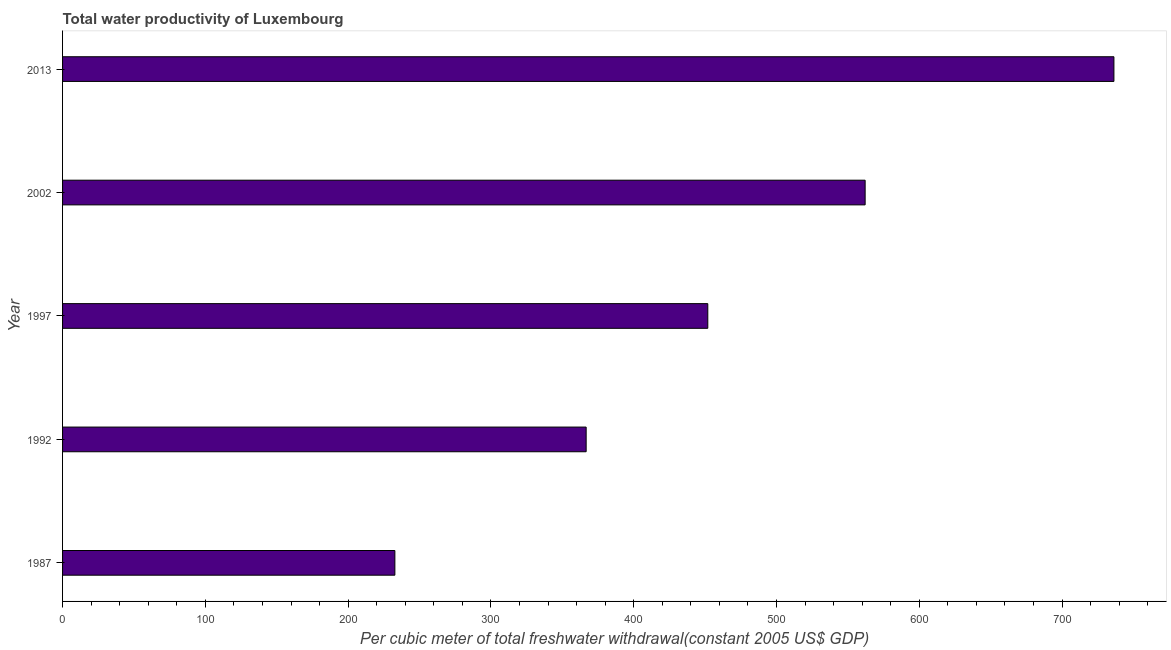Does the graph contain any zero values?
Ensure brevity in your answer.  No. Does the graph contain grids?
Provide a short and direct response. No. What is the title of the graph?
Your answer should be compact. Total water productivity of Luxembourg. What is the label or title of the X-axis?
Your answer should be compact. Per cubic meter of total freshwater withdrawal(constant 2005 US$ GDP). What is the total water productivity in 1987?
Your answer should be compact. 232.74. Across all years, what is the maximum total water productivity?
Provide a short and direct response. 736.35. Across all years, what is the minimum total water productivity?
Provide a short and direct response. 232.74. In which year was the total water productivity maximum?
Ensure brevity in your answer.  2013. What is the sum of the total water productivity?
Ensure brevity in your answer.  2349.81. What is the difference between the total water productivity in 1987 and 2013?
Your answer should be very brief. -503.6. What is the average total water productivity per year?
Ensure brevity in your answer.  469.96. What is the median total water productivity?
Make the answer very short. 451.9. In how many years, is the total water productivity greater than 360 US$?
Ensure brevity in your answer.  4. What is the ratio of the total water productivity in 1987 to that in 1997?
Ensure brevity in your answer.  0.52. Is the total water productivity in 1987 less than that in 2013?
Make the answer very short. Yes. What is the difference between the highest and the second highest total water productivity?
Offer a very short reply. 174.24. Is the sum of the total water productivity in 1987 and 1992 greater than the maximum total water productivity across all years?
Offer a terse response. No. What is the difference between the highest and the lowest total water productivity?
Provide a succinct answer. 503.6. How many bars are there?
Your response must be concise. 5. What is the difference between two consecutive major ticks on the X-axis?
Ensure brevity in your answer.  100. What is the Per cubic meter of total freshwater withdrawal(constant 2005 US$ GDP) of 1987?
Offer a terse response. 232.74. What is the Per cubic meter of total freshwater withdrawal(constant 2005 US$ GDP) of 1992?
Ensure brevity in your answer.  366.71. What is the Per cubic meter of total freshwater withdrawal(constant 2005 US$ GDP) of 1997?
Keep it short and to the point. 451.9. What is the Per cubic meter of total freshwater withdrawal(constant 2005 US$ GDP) in 2002?
Your answer should be compact. 562.1. What is the Per cubic meter of total freshwater withdrawal(constant 2005 US$ GDP) in 2013?
Your response must be concise. 736.35. What is the difference between the Per cubic meter of total freshwater withdrawal(constant 2005 US$ GDP) in 1987 and 1992?
Your answer should be compact. -133.97. What is the difference between the Per cubic meter of total freshwater withdrawal(constant 2005 US$ GDP) in 1987 and 1997?
Your answer should be very brief. -219.16. What is the difference between the Per cubic meter of total freshwater withdrawal(constant 2005 US$ GDP) in 1987 and 2002?
Keep it short and to the point. -329.36. What is the difference between the Per cubic meter of total freshwater withdrawal(constant 2005 US$ GDP) in 1987 and 2013?
Give a very brief answer. -503.6. What is the difference between the Per cubic meter of total freshwater withdrawal(constant 2005 US$ GDP) in 1992 and 1997?
Keep it short and to the point. -85.19. What is the difference between the Per cubic meter of total freshwater withdrawal(constant 2005 US$ GDP) in 1992 and 2002?
Give a very brief answer. -195.39. What is the difference between the Per cubic meter of total freshwater withdrawal(constant 2005 US$ GDP) in 1992 and 2013?
Your answer should be very brief. -369.63. What is the difference between the Per cubic meter of total freshwater withdrawal(constant 2005 US$ GDP) in 1997 and 2002?
Provide a short and direct response. -110.2. What is the difference between the Per cubic meter of total freshwater withdrawal(constant 2005 US$ GDP) in 1997 and 2013?
Ensure brevity in your answer.  -284.44. What is the difference between the Per cubic meter of total freshwater withdrawal(constant 2005 US$ GDP) in 2002 and 2013?
Your answer should be very brief. -174.24. What is the ratio of the Per cubic meter of total freshwater withdrawal(constant 2005 US$ GDP) in 1987 to that in 1992?
Your response must be concise. 0.64. What is the ratio of the Per cubic meter of total freshwater withdrawal(constant 2005 US$ GDP) in 1987 to that in 1997?
Your answer should be compact. 0.52. What is the ratio of the Per cubic meter of total freshwater withdrawal(constant 2005 US$ GDP) in 1987 to that in 2002?
Keep it short and to the point. 0.41. What is the ratio of the Per cubic meter of total freshwater withdrawal(constant 2005 US$ GDP) in 1987 to that in 2013?
Your response must be concise. 0.32. What is the ratio of the Per cubic meter of total freshwater withdrawal(constant 2005 US$ GDP) in 1992 to that in 1997?
Provide a short and direct response. 0.81. What is the ratio of the Per cubic meter of total freshwater withdrawal(constant 2005 US$ GDP) in 1992 to that in 2002?
Offer a very short reply. 0.65. What is the ratio of the Per cubic meter of total freshwater withdrawal(constant 2005 US$ GDP) in 1992 to that in 2013?
Provide a succinct answer. 0.5. What is the ratio of the Per cubic meter of total freshwater withdrawal(constant 2005 US$ GDP) in 1997 to that in 2002?
Your response must be concise. 0.8. What is the ratio of the Per cubic meter of total freshwater withdrawal(constant 2005 US$ GDP) in 1997 to that in 2013?
Provide a succinct answer. 0.61. What is the ratio of the Per cubic meter of total freshwater withdrawal(constant 2005 US$ GDP) in 2002 to that in 2013?
Ensure brevity in your answer.  0.76. 